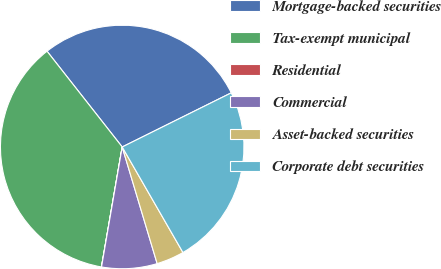<chart> <loc_0><loc_0><loc_500><loc_500><pie_chart><fcel>Mortgage-backed securities<fcel>Tax-exempt municipal<fcel>Residential<fcel>Commercial<fcel>Asset-backed securities<fcel>Corporate debt securities<nl><fcel>28.26%<fcel>36.68%<fcel>0.01%<fcel>7.35%<fcel>3.68%<fcel>24.02%<nl></chart> 